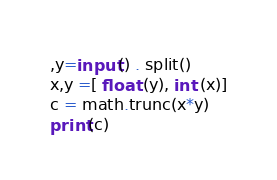Convert code to text. <code><loc_0><loc_0><loc_500><loc_500><_Python_>,y=input() . split()
x,y =[ float (y), int (x)]
c = math.trunc(x*y)
print(c)</code> 